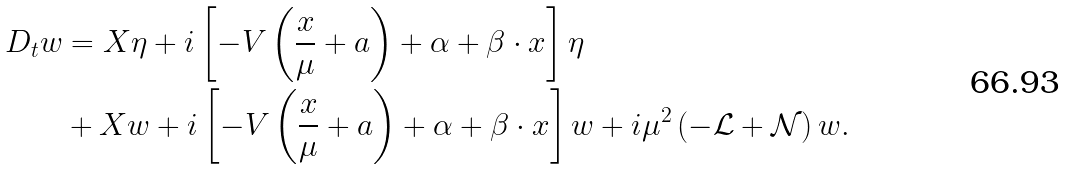<formula> <loc_0><loc_0><loc_500><loc_500>\ D _ { t } w & = X \eta + i \left [ - V \left ( \frac { x } { \mu } + a \right ) + \alpha + \beta \cdot x \right ] \eta \\ & + X w + i \left [ - V \left ( \frac { x } { \mu } + a \right ) + \alpha + \beta \cdot x \right ] w + i \mu ^ { 2 } \left ( - \mathcal { L } + \mathcal { N } \right ) w .</formula> 